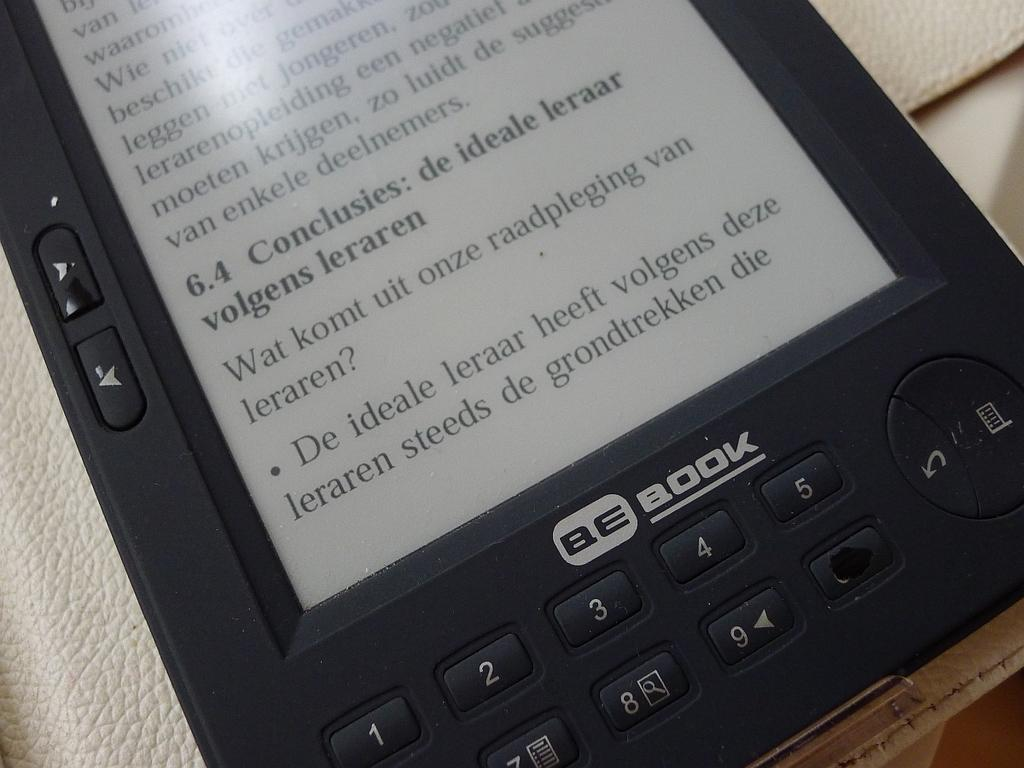<image>
Provide a brief description of the given image. A BE Book with number keys 1 through 9 with the 0 blacked out. 